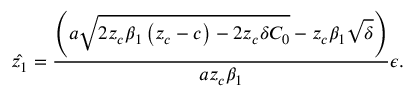<formula> <loc_0><loc_0><loc_500><loc_500>\hat { z _ { 1 } } = \frac { \left ( a \sqrt { 2 z _ { c } \beta _ { 1 } \left ( z _ { c } - c \right ) - 2 z _ { c } \delta C _ { 0 } } - z _ { c } \beta _ { 1 } \sqrt { \delta } \right ) } { a z _ { c } \beta _ { 1 } } \epsilon .</formula> 